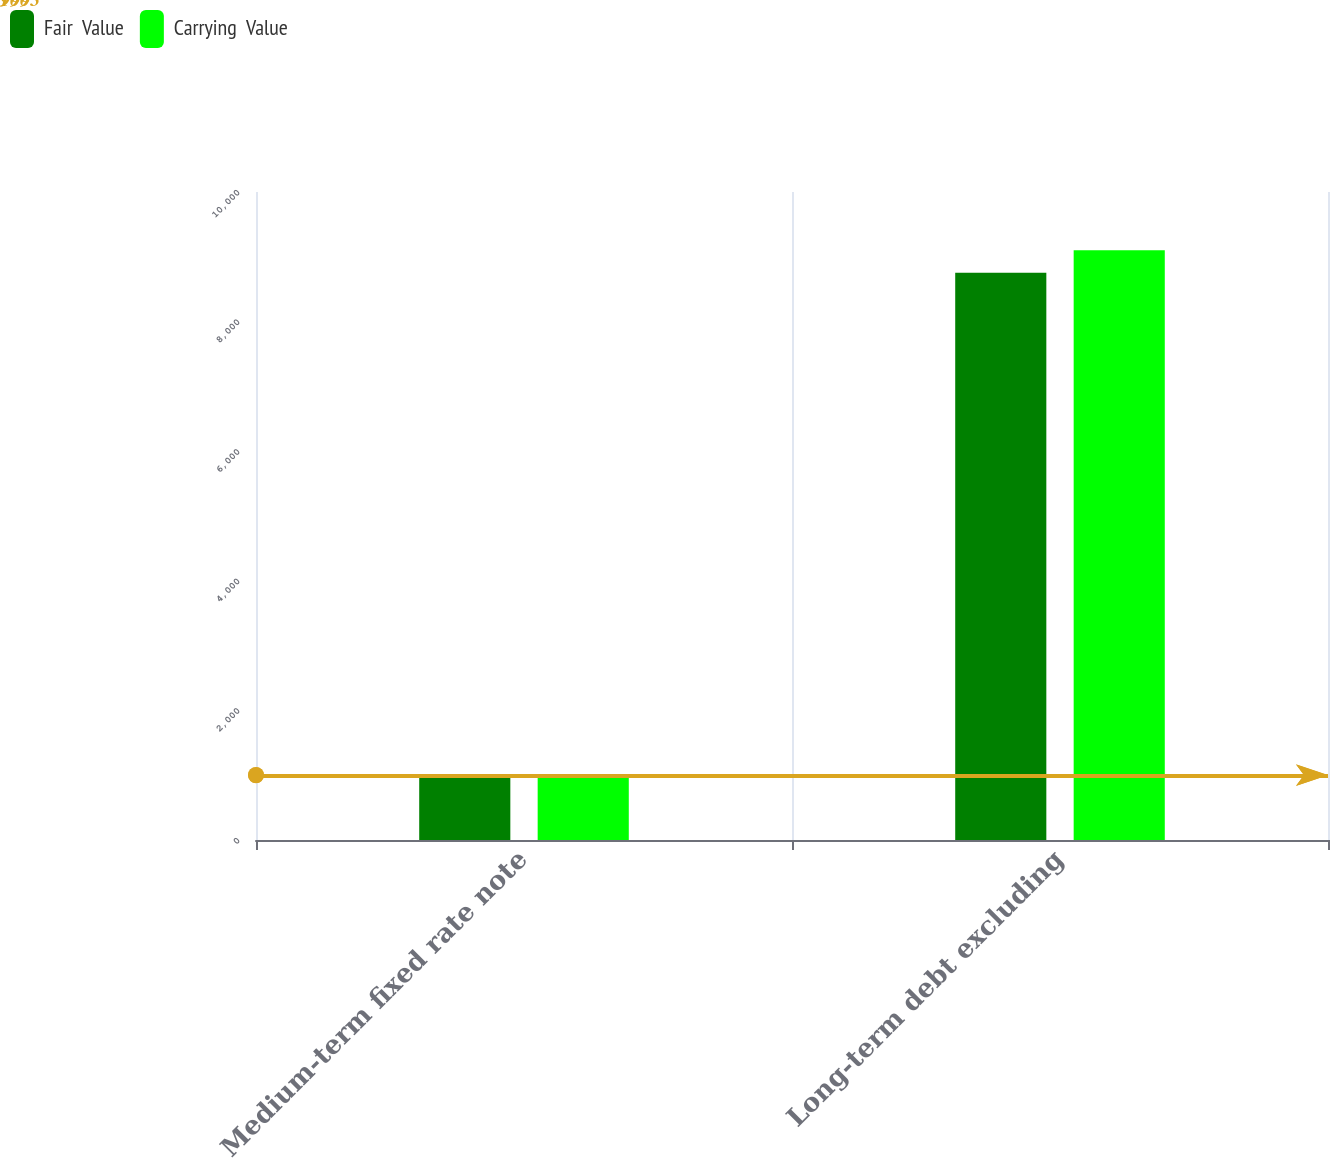<chart> <loc_0><loc_0><loc_500><loc_500><stacked_bar_chart><ecel><fcel>Medium-term fixed rate note<fcel>Long-term debt excluding<nl><fcel>Fair  Value<fcel>999<fcel>8753<nl><fcel>Carrying  Value<fcel>1003<fcel>9101<nl></chart> 